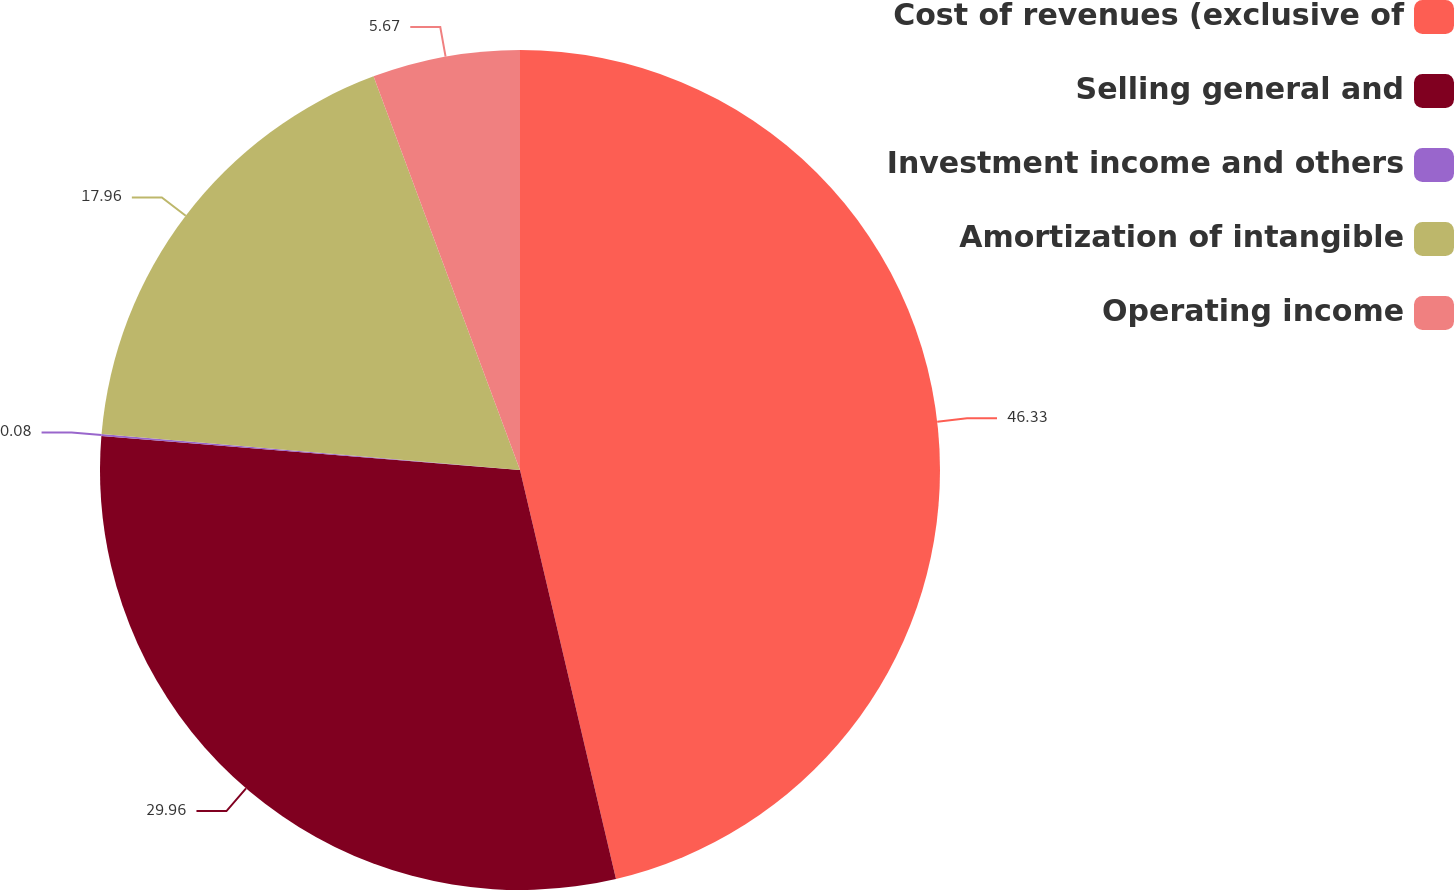<chart> <loc_0><loc_0><loc_500><loc_500><pie_chart><fcel>Cost of revenues (exclusive of<fcel>Selling general and<fcel>Investment income and others<fcel>Amortization of intangible<fcel>Operating income<nl><fcel>46.33%<fcel>29.96%<fcel>0.08%<fcel>17.96%<fcel>5.67%<nl></chart> 